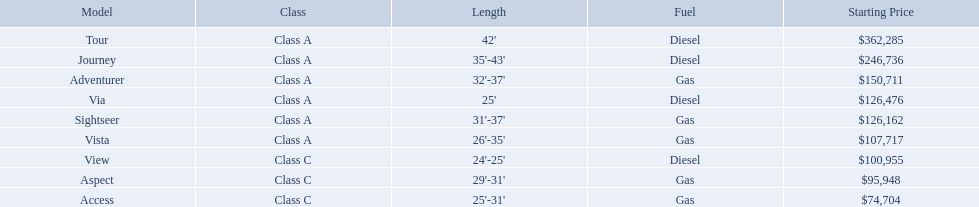Which of the models in the table use diesel fuel? Tour, Journey, Via, View. Of these models, which are class a? Tour, Journey, Via. Which of them are greater than 35' in length? Tour, Journey. Which of the two models is more expensive? Tour. Which models are manufactured by winnebago industries? Tour, Journey, Adventurer, Via, Sightseer, Vista, View, Aspect, Access. What type of fuel does each model require? Diesel, Diesel, Gas, Diesel, Gas, Gas, Diesel, Gas, Gas. And between the tour and aspect, which runs on diesel? Tour. What models are available from winnebago industries? Tour, Journey, Adventurer, Via, Sightseer, Vista, View, Aspect, Access. What are their starting prices? $362,285, $246,736, $150,711, $126,476, $126,162, $107,717, $100,955, $95,948, $74,704. Which model has the most costly starting price? Tour. What are the prices? $362,285, $246,736, $150,711, $126,476, $126,162, $107,717, $100,955, $95,948, $74,704. What is the top price? $362,285. What model has this price? Tour. What are all of the winnebago models? Tour, Journey, Adventurer, Via, Sightseer, Vista, View, Aspect, Access. What are their prices? $362,285, $246,736, $150,711, $126,476, $126,162, $107,717, $100,955, $95,948, $74,704. And which model costs the most? Tour. What are the costs? $362,285, $246,736, $150,711, $126,476, $126,162, $107,717, $100,955, $95,948, $74,704. What is the highest cost? $362,285. Which version has this cost? Tour. What models does winnebago industries offer? Tour, Journey, Adventurer, Via, Sightseer, Vista, View, Aspect, Access. What are their starting costs? $362,285, $246,736, $150,711, $126,476, $126,162, $107,717, $100,955, $95,948, $74,704. Which model has the priciest beginning price? Tour. Which of the models in the table run on diesel fuel? Tour, Journey, Via, View. Of these models, which are type a? Tour, Journey, Via. Which of them have a length greater than 35 feet? Tour, Journey. Which of the two models is pricier? Tour. Can you list the different winnebago models? Tour, Journey, Adventurer, Via, Sightseer, Vista, View, Aspect, Access. Which ones run on diesel? Tour, Journey, Sightseer, View. Which model has the greatest length? Tour, Journey. Which one begins with the highest price? Tour. What are the different models of winnebago? Tour, Journey, Adventurer, Via, Sightseer, Vista, View, Aspect, Access. Which of these models are diesel-powered? Tour, Journey, Sightseer, View. Which one is the longest? Tour, Journey. And which model has the highest starting price? Tour. Which model has the most affordable initial cost? Access. Which model has the second most expensive starting price? Journey. I'm looking to parse the entire table for insights. Could you assist me with that? {'header': ['Model', 'Class', 'Length', 'Fuel', 'Starting Price'], 'rows': [['Tour', 'Class A', "42'", 'Diesel', '$362,285'], ['Journey', 'Class A', "35'-43'", 'Diesel', '$246,736'], ['Adventurer', 'Class A', "32'-37'", 'Gas', '$150,711'], ['Via', 'Class A', "25'", 'Diesel', '$126,476'], ['Sightseer', 'Class A', "31'-37'", 'Gas', '$126,162'], ['Vista', 'Class A', "26'-35'", 'Gas', '$107,717'], ['View', 'Class C', "24'-25'", 'Diesel', '$100,955'], ['Aspect', 'Class C', "29'-31'", 'Gas', '$95,948'], ['Access', 'Class C', "25'-31'", 'Gas', '$74,704']]} Which model has the top price in the winnebago industry? Tour. What are the various pricing options? $362,285, $246,736, $150,711, $126,476, $126,162, $107,717, $100,955, $95,948, $74,704. What is the peak price? $362,285. What model bears this price? Tour. 